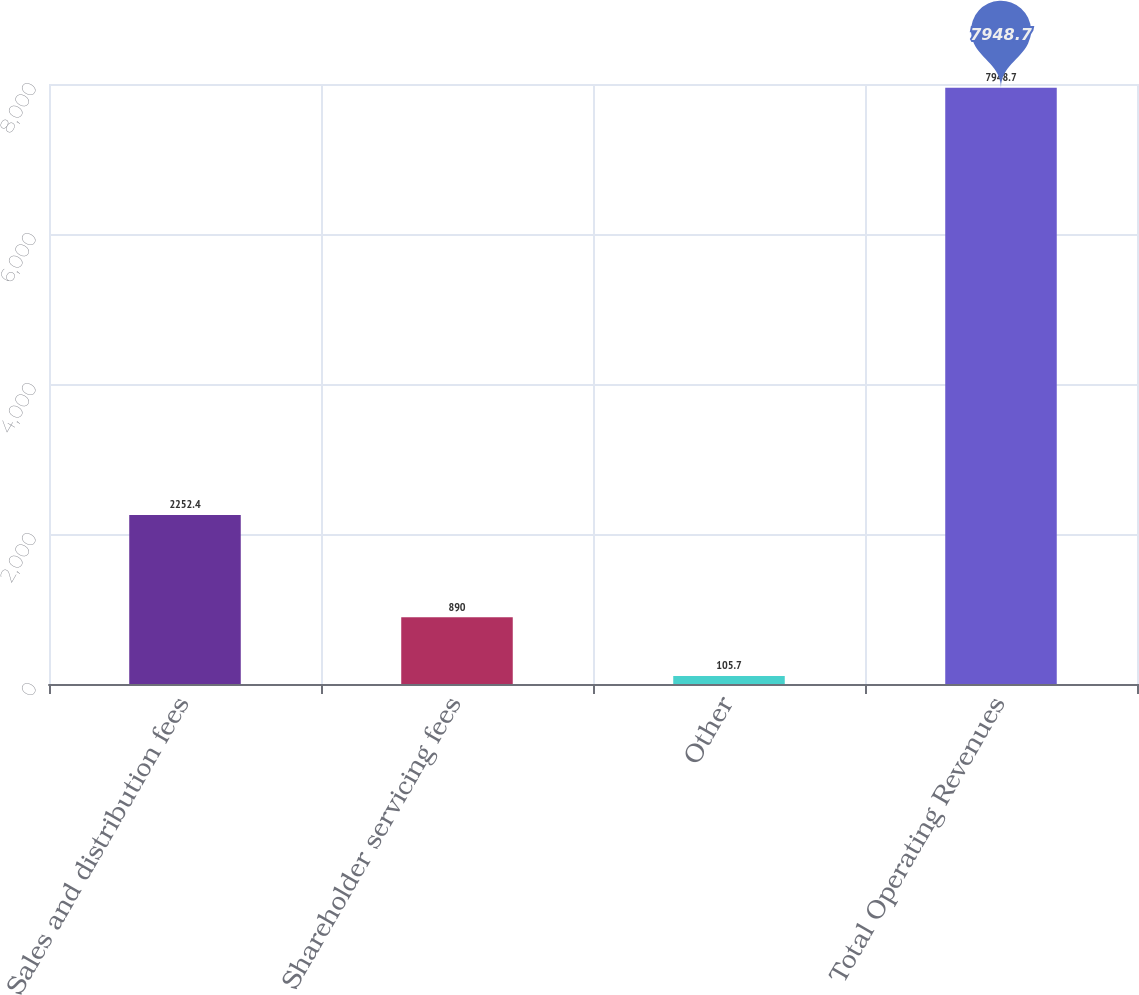<chart> <loc_0><loc_0><loc_500><loc_500><bar_chart><fcel>Sales and distribution fees<fcel>Shareholder servicing fees<fcel>Other<fcel>Total Operating Revenues<nl><fcel>2252.4<fcel>890<fcel>105.7<fcel>7948.7<nl></chart> 